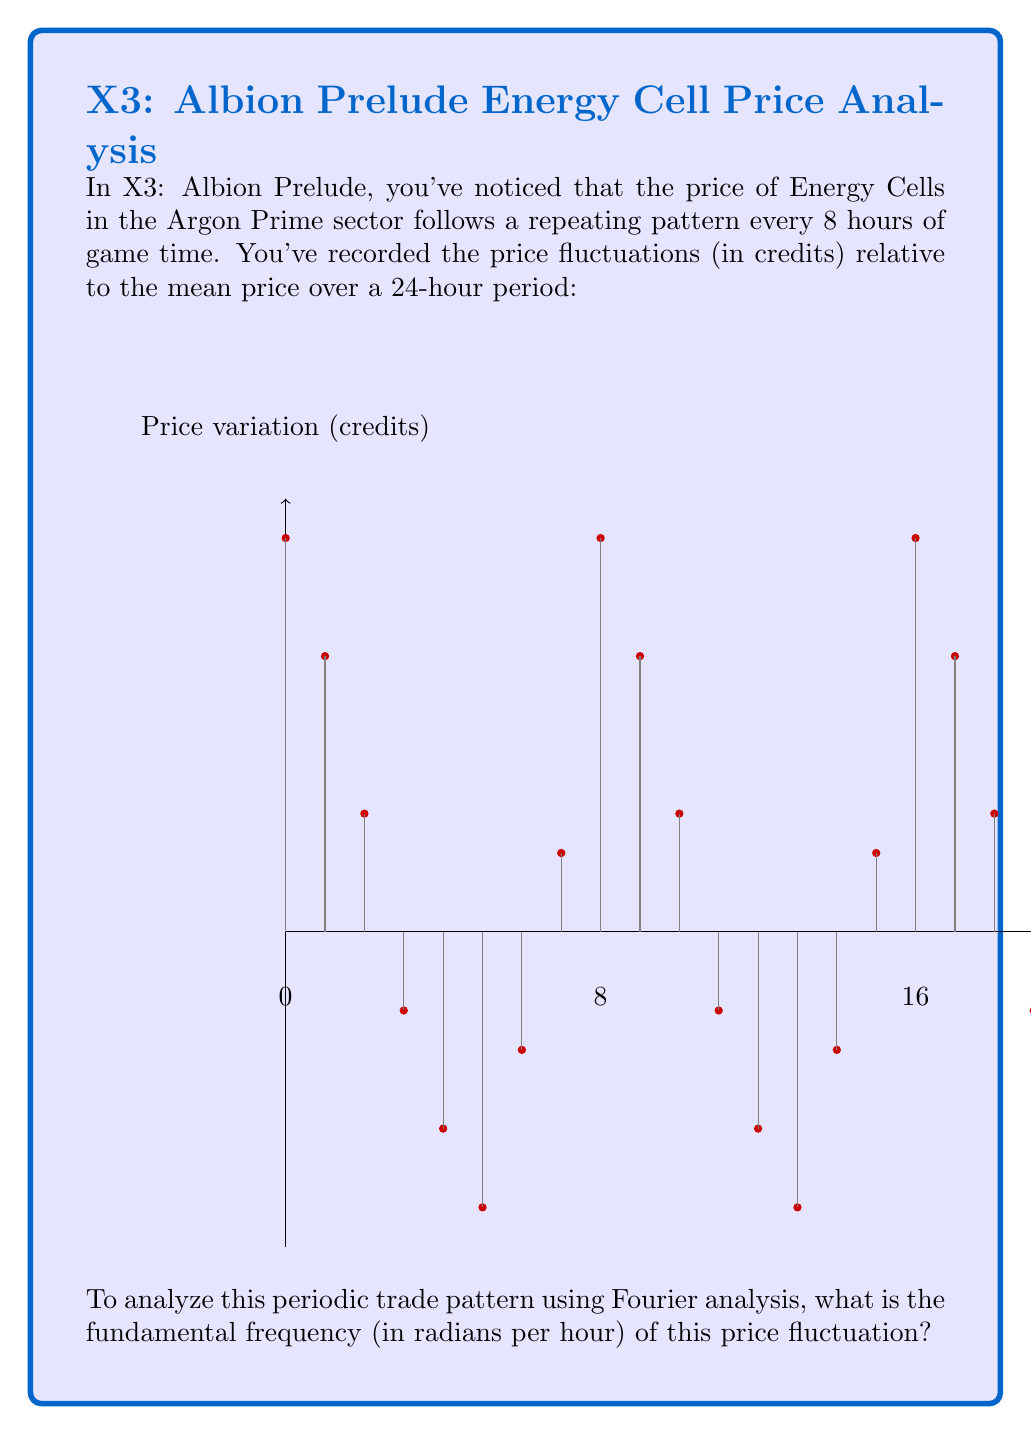Solve this math problem. Let's approach this step-by-step:

1) In Fourier analysis, the fundamental frequency is the lowest frequency component of a periodic signal. It's determined by the period of the signal.

2) From the graph and the question, we can see that the pattern repeats every 8 hours. This means the period (T) is 8 hours.

3) The fundamental frequency in Hz (cycles per hour) is given by:

   $f = \frac{1}{T} = \frac{1}{8}$ cycles/hour

4) However, the question asks for the frequency in radians per hour. To convert from Hz to radians/hour, we multiply by $2\pi$:

   $\omega = 2\pi f = 2\pi \cdot \frac{1}{8}$

5) Simplifying:

   $\omega = \frac{\pi}{4}$ radians/hour

This $\frac{\pi}{4}$ radians/hour is the fundamental frequency of the price fluctuation in the game's economy.
Answer: $\frac{\pi}{4}$ radians/hour 